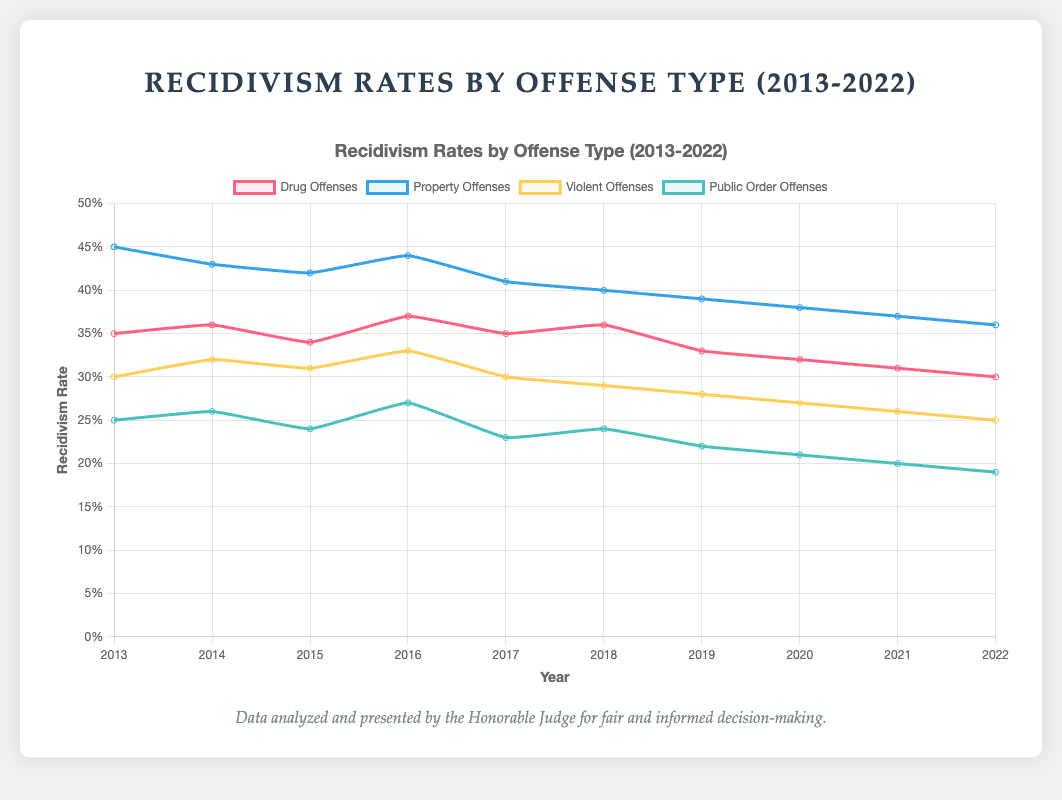What is the trend in recidivism rates for drug offenses between 2013 and 2022? The recidivism rate for drug offenses starts at 0.35 in 2013 and generally decreases over the years, reaching 0.30 in 2022.
Answer: A decreasing trend Which type of offense had the highest recidivism rate in 2013? In 2013, property offenses had the highest recidivism rate at 0.45.
Answer: Property offenses By how much did the recidivism rate for public order offenses decrease from 2013 to 2022? The rate for public order offenses was 0.25 in 2013 and decreased to 0.19 in 2022. The difference is 0.25 - 0.19 = 0.06.
Answer: 0.06 Which year had the highest recidivism rate for violent offenses? The year with the highest recidivism rate for violent offenses was 2016, with a rate of 0.33.
Answer: 2016 Compare the recidivism rates for property offenses and drug offenses in 2015. Which was higher and by how much? In 2015, property offenses had a rate of 0.42, while drug offenses had a rate of 0.34. The difference is 0.42 - 0.34 = 0.08.
Answer: Property offenses by 0.08 What is the average recidivism rate for violent offenses from 2013 to 2022? Sum the rates for each year (0.30 + 0.32 + 0.31 + 0.33 + 0.30 + 0.29 + 0.28 + 0.27 + 0.26 + 0.25) = 2.91, then divide by the number of years (10). The average is 2.91 / 10 = 0.291.
Answer: 0.291 How did the recidivism rates for public order offenses change from 2016 to 2017? The rate for public order offenses was 0.27 in 2016 and decreased to 0.23 in 2017. The change is 0.27 - 0.23 = 0.04.
Answer: Decreased by 0.04 Which year saw the lowest recidivism rate for drug offenses during the decade? The lowest recidivism rate for drug offenses was in 2022, with a rate of 0.30.
Answer: 2022 In which year did property offenses and violent offenses share the same recidivism rate, and what was that rate? There is no year between 2013 and 2022 when property offenses and violent offenses had the same recidivism rate.
Answer: None How did the recidivism rate for public order offenses in 2014 compare to the recidivism rate for drug offenses in 2020? The recidivism rate for public order offenses in 2014 was 0.26, and for drug offenses in 2020, it was 0.32. The drug offenses rate in 2020 is higher by 0.32 - 0.26 = 0.06.
Answer: Drug offenses in 2020 were higher by 0.06 